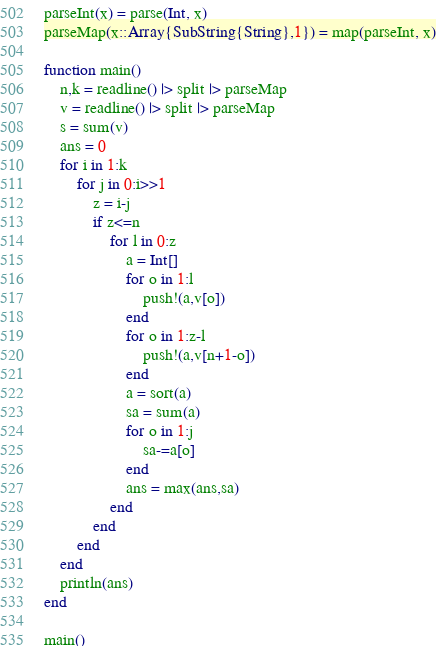Convert code to text. <code><loc_0><loc_0><loc_500><loc_500><_Julia_>parseInt(x) = parse(Int, x)
parseMap(x::Array{SubString{String},1}) = map(parseInt, x)

function main()
	n,k = readline() |> split |> parseMap
	v = readline() |> split |> parseMap
	s = sum(v)
	ans = 0
	for i in 1:k
		for j in 0:i>>1
			z = i-j
			if z<=n
				for l in 0:z
					a = Int[]
					for o in 1:l
						push!(a,v[o])
					end
					for o in 1:z-l
						push!(a,v[n+1-o])
					end
					a = sort(a)
					sa = sum(a)
					for o in 1:j
						sa-=a[o]
					end
					ans = max(ans,sa)
				end
			end
		end
	end
	println(ans)
end

main()</code> 